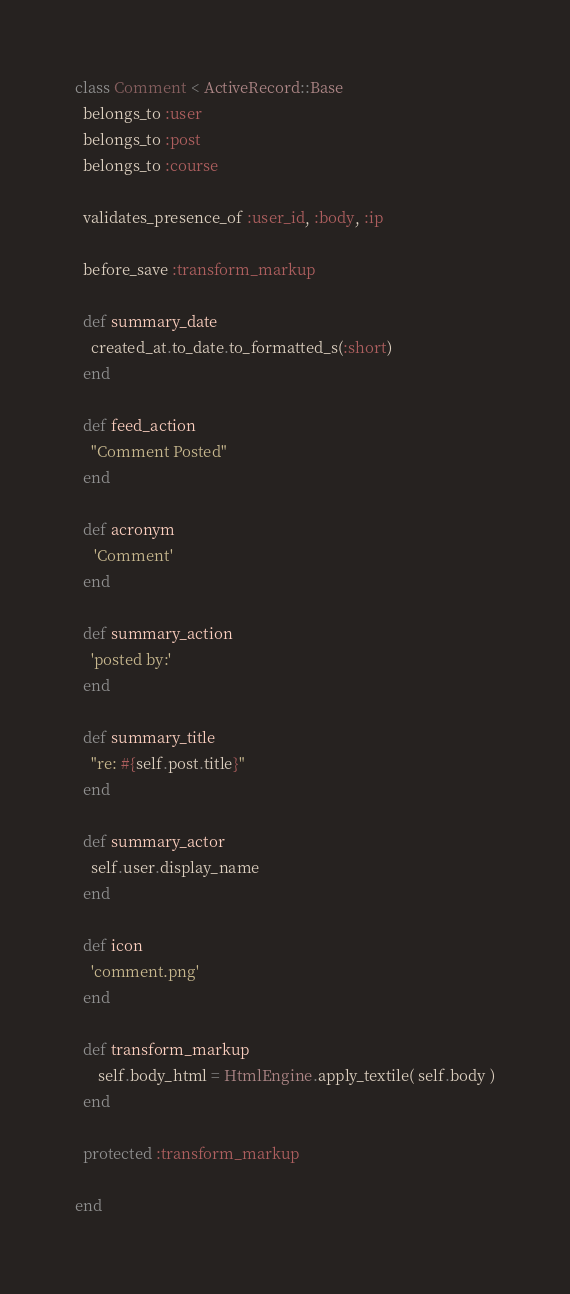Convert code to text. <code><loc_0><loc_0><loc_500><loc_500><_Ruby_>class Comment < ActiveRecord::Base
  belongs_to :user
  belongs_to :post
  belongs_to :course
  
  validates_presence_of :user_id, :body, :ip
  
  before_save :transform_markup
  
  def summary_date
    created_at.to_date.to_formatted_s(:short)
  end
  
  def feed_action
    "Comment Posted"
  end
  
  def acronym
     'Comment'
  end
  
  def summary_action
    'posted by:'
  end
  
  def summary_title
    "re: #{self.post.title}"
  end
  
  def summary_actor
    self.user.display_name
  end
  
  def icon
    'comment.png'
  end
  
  def transform_markup
	  self.body_html = HtmlEngine.apply_textile( self.body )
  end
  
  protected :transform_markup
  
end
</code> 